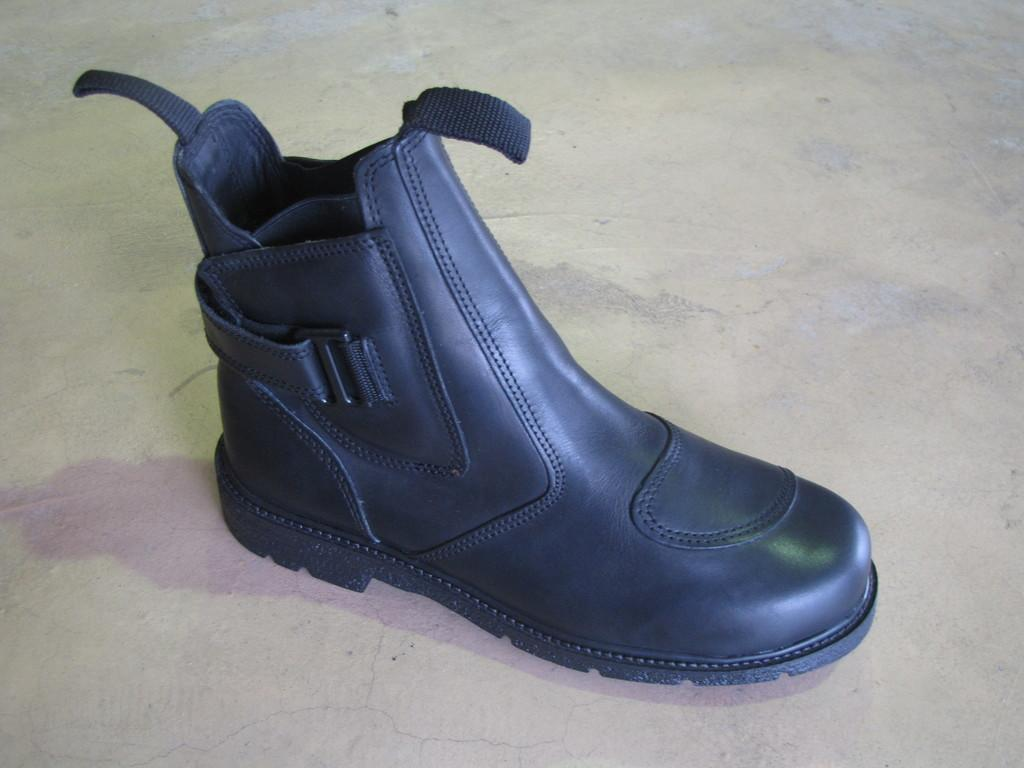What object is on the floor in the image? There is a shoe on the floor in the image. What color is the shoe? The shoe is black in color. What type of space exploration is depicted in the image? There is no space exploration depicted in the image; it features a black shoe on the floor. How does the shoe compare to other shoes in terms of style and design? The image only shows one shoe, so it cannot be compared to other shoes in terms of style and design. 